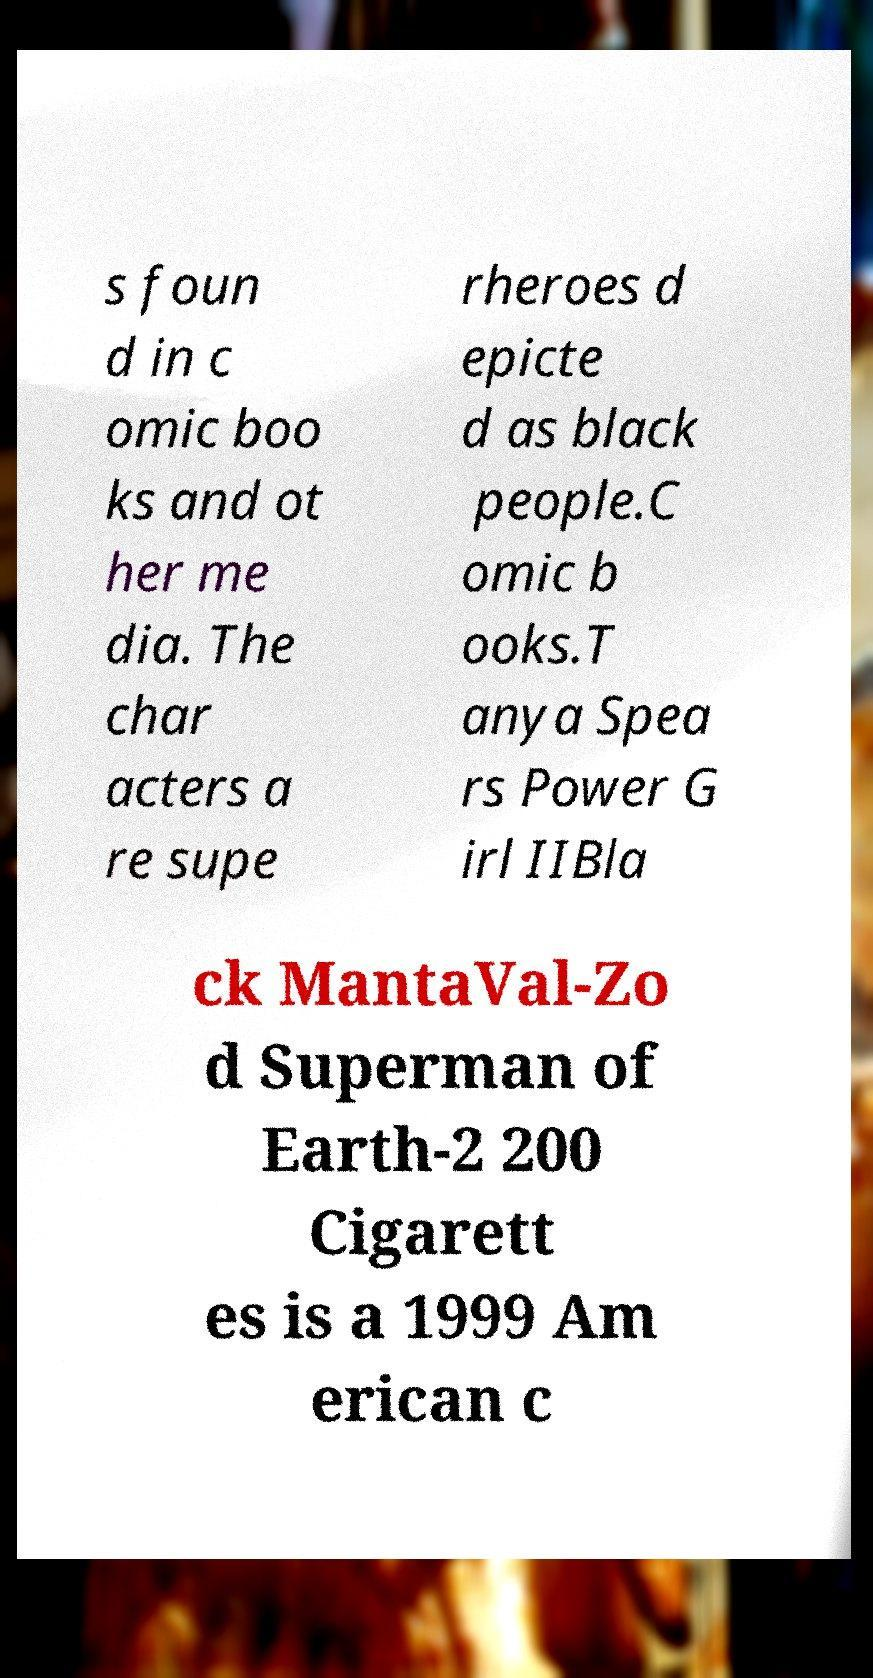I need the written content from this picture converted into text. Can you do that? s foun d in c omic boo ks and ot her me dia. The char acters a re supe rheroes d epicte d as black people.C omic b ooks.T anya Spea rs Power G irl IIBla ck MantaVal-Zo d Superman of Earth-2 200 Cigarett es is a 1999 Am erican c 